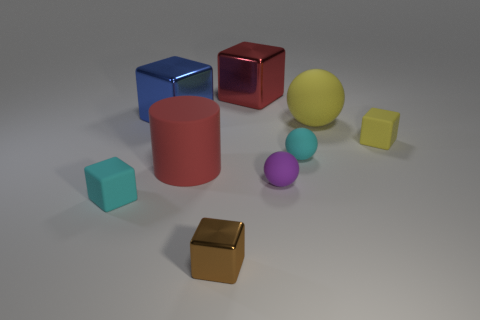What is the small block that is both on the right side of the big red matte cylinder and in front of the tiny yellow block made of?
Offer a very short reply. Metal. What color is the cylinder?
Your answer should be very brief. Red. Is there anything else that has the same material as the big red block?
Your response must be concise. Yes. What is the shape of the cyan matte object that is on the right side of the brown cube?
Your answer should be very brief. Sphere. There is a tiny cyan rubber object in front of the tiny rubber ball to the left of the small cyan sphere; are there any tiny metal cubes right of it?
Offer a terse response. Yes. Are there any other things that have the same shape as the small yellow matte object?
Give a very brief answer. Yes. Are there any large blue shiny things?
Provide a succinct answer. Yes. Does the large red thing in front of the small yellow thing have the same material as the tiny cube on the right side of the large yellow ball?
Offer a very short reply. Yes. There is a red matte cylinder in front of the yellow matte object on the left side of the object to the right of the yellow sphere; what size is it?
Make the answer very short. Large. How many brown cubes have the same material as the tiny cyan cube?
Ensure brevity in your answer.  0. 